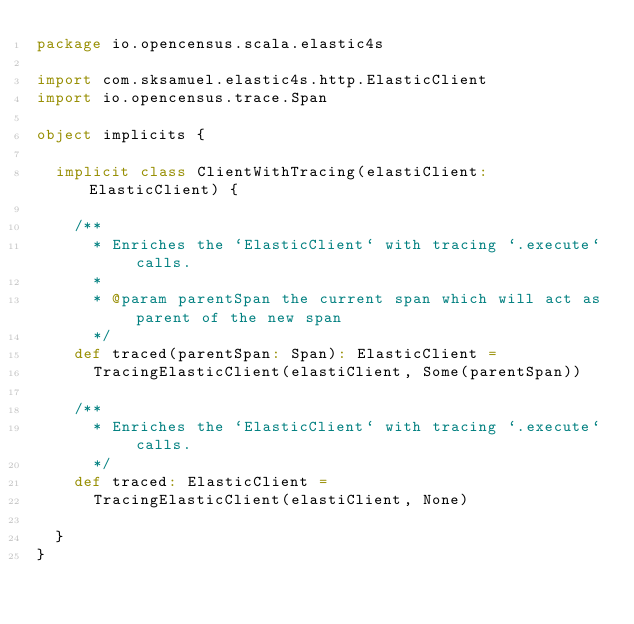Convert code to text. <code><loc_0><loc_0><loc_500><loc_500><_Scala_>package io.opencensus.scala.elastic4s

import com.sksamuel.elastic4s.http.ElasticClient
import io.opencensus.trace.Span

object implicits {

  implicit class ClientWithTracing(elastiClient: ElasticClient) {

    /**
      * Enriches the `ElasticClient` with tracing `.execute` calls.
      *
      * @param parentSpan the current span which will act as parent of the new span
      */
    def traced(parentSpan: Span): ElasticClient =
      TracingElasticClient(elastiClient, Some(parentSpan))

    /**
      * Enriches the `ElasticClient` with tracing `.execute` calls.
      */
    def traced: ElasticClient =
      TracingElasticClient(elastiClient, None)

  }
}
</code> 